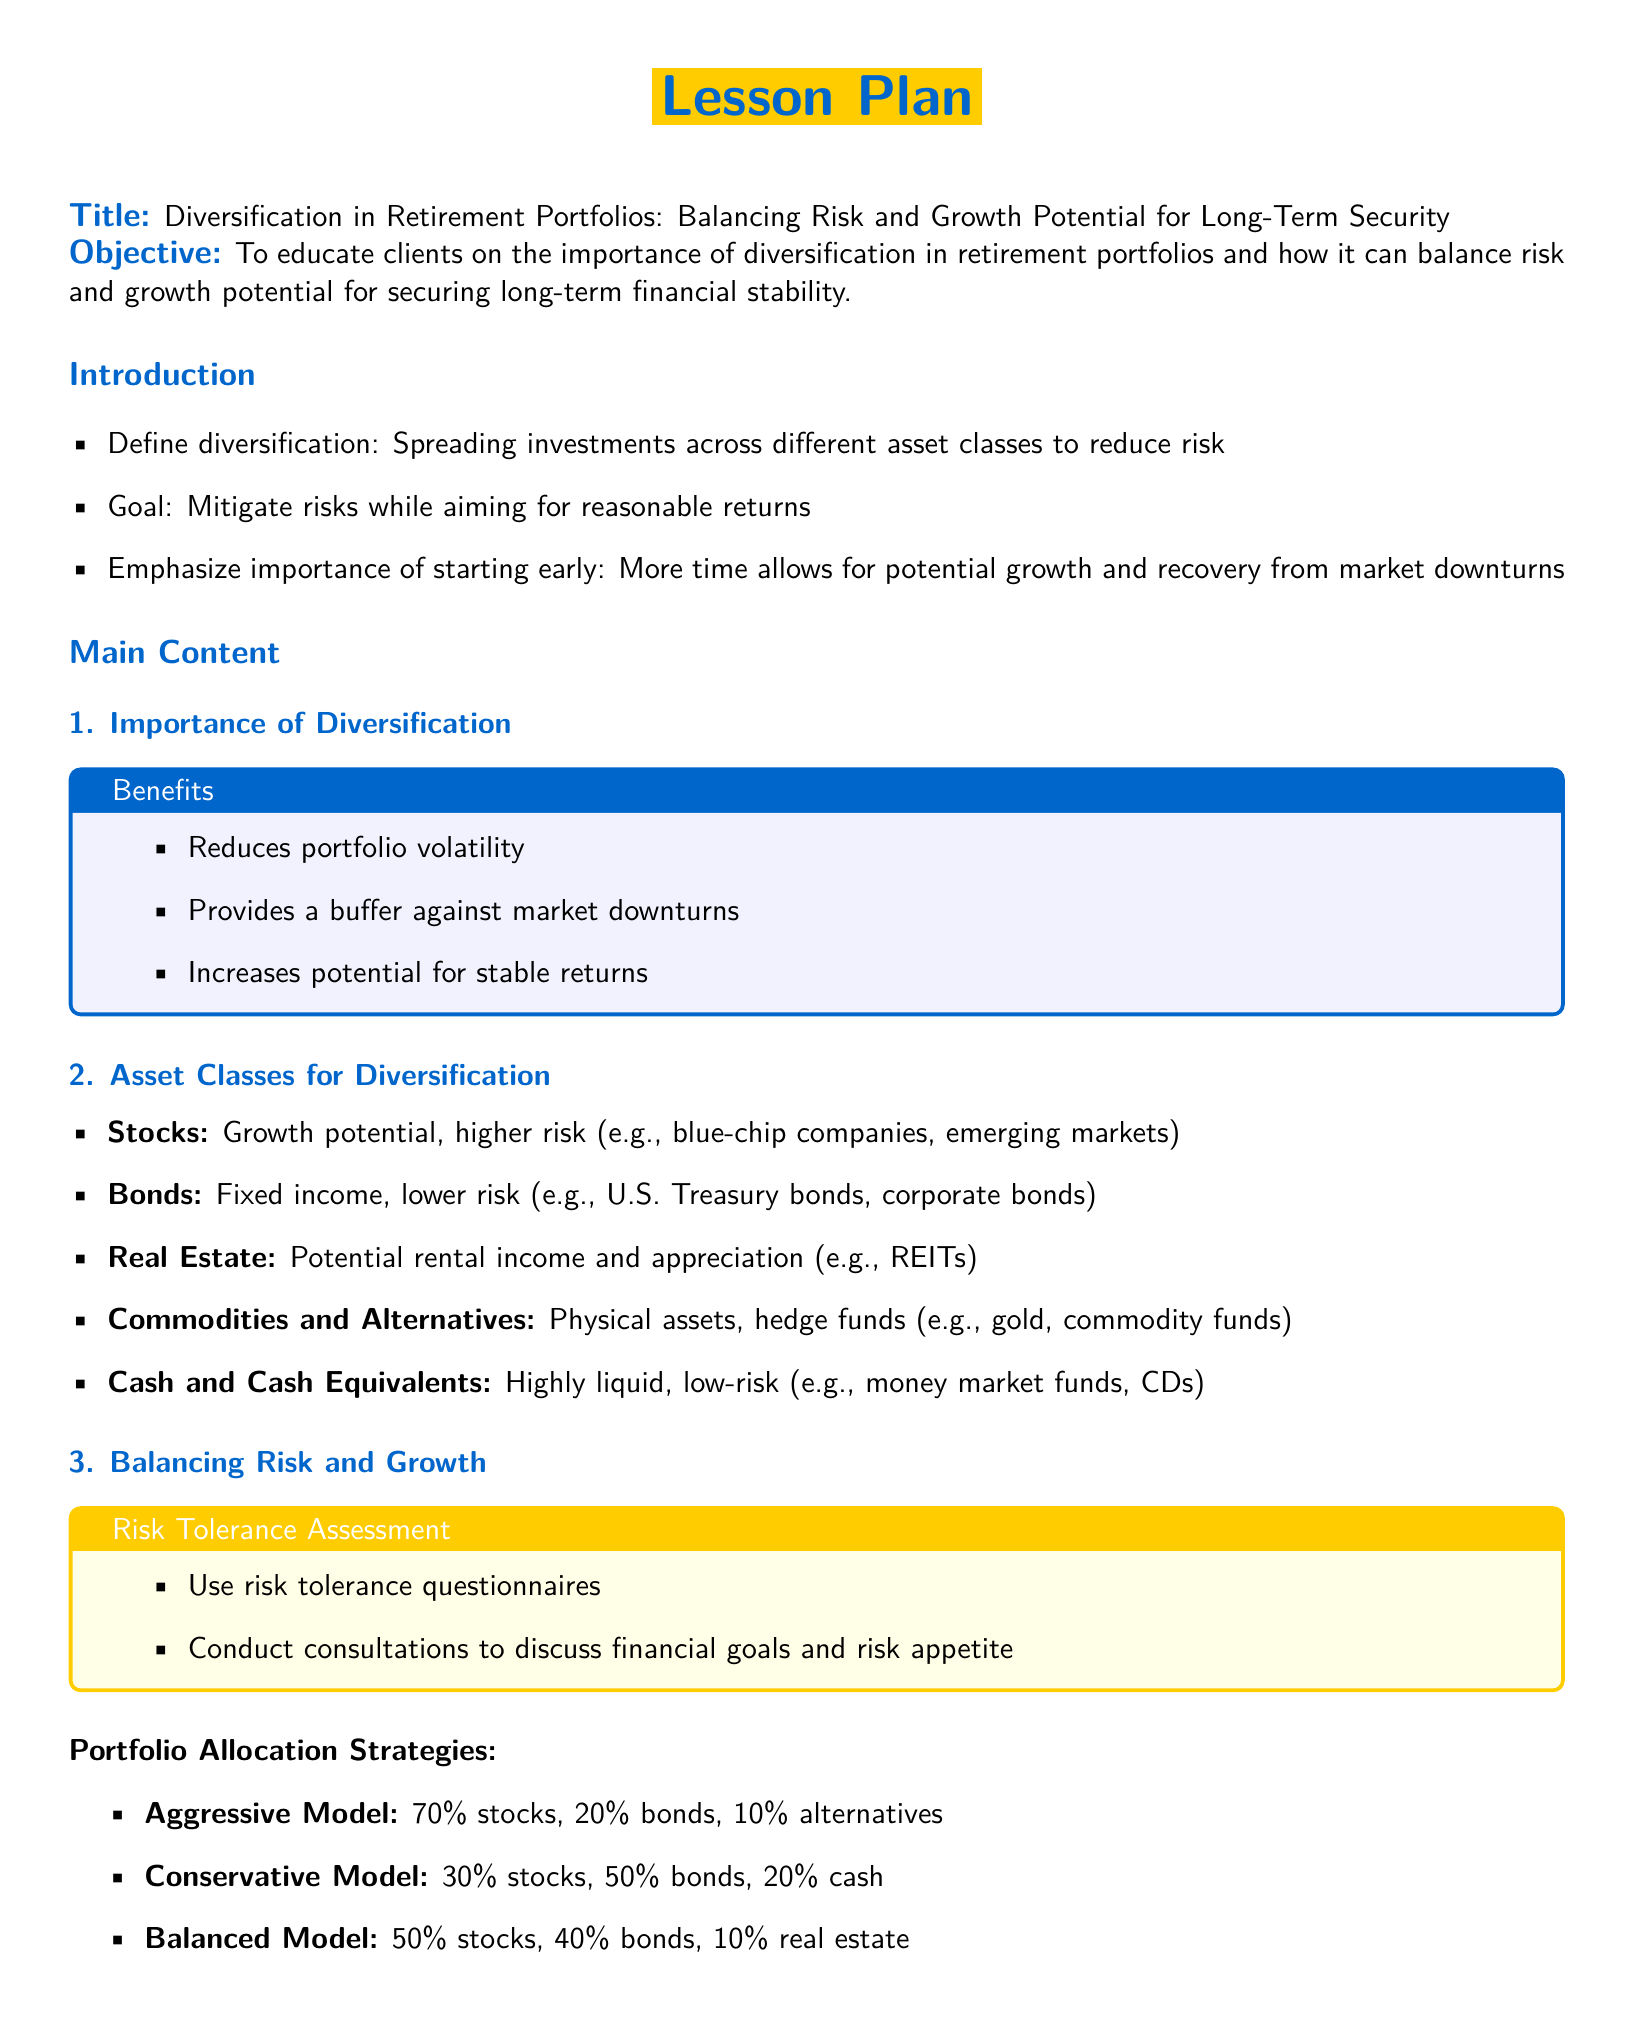What is the title of the lesson plan? The title of the lesson plan can be found at the beginning of the document.
Answer: Diversification in Retirement Portfolios: Balancing Risk and Growth Potential for Long-Term Security What are the main benefits of diversification? The benefits of diversification are listed in a highlighted box in the document.
Answer: Reduces portfolio volatility, provides a buffer against market downturns, increases potential for stable returns What is included in the conservative portfolio model? The conservative model's allocation is specified in the document.
Answer: 30% stocks, 50% bonds, 20% cash What is the risk tolerance assessment method mentioned? The document provides specific methods for assessing risk tolerance.
Answer: Use risk tolerance questionnaires What should clients regularly do according to the actionable steps? The conclusion section outlines actionable steps for clients.
Answer: Regularly review and rebalance the portfolio to align with changing financial goals What is the goal of diversification mentioned in the document? The stated goal can be found in the introduction section.
Answer: Mitigate risks while aiming for reasonable returns How many asset classes are recommended for diversification? The asset classes listed in the main content section can be counted.
Answer: Five What is the focus of the lesson plan? The lesson plan clearly states its focus in the objective section.
Answer: Educate clients on the importance of diversification in retirement portfolios What is the percentage allocation of stocks in the aggressive model? The allocation details for the aggressive model are given in the document.
Answer: 70% 